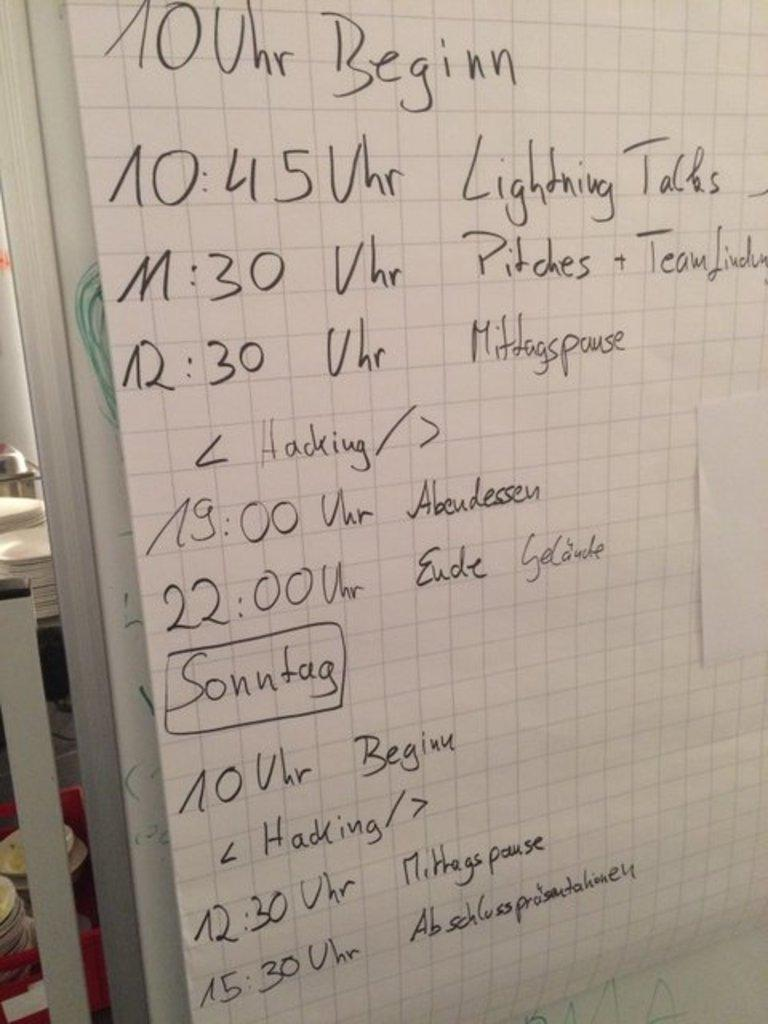<image>
Render a clear and concise summary of the photo. A whiteboard has Lightning talks written on it. 